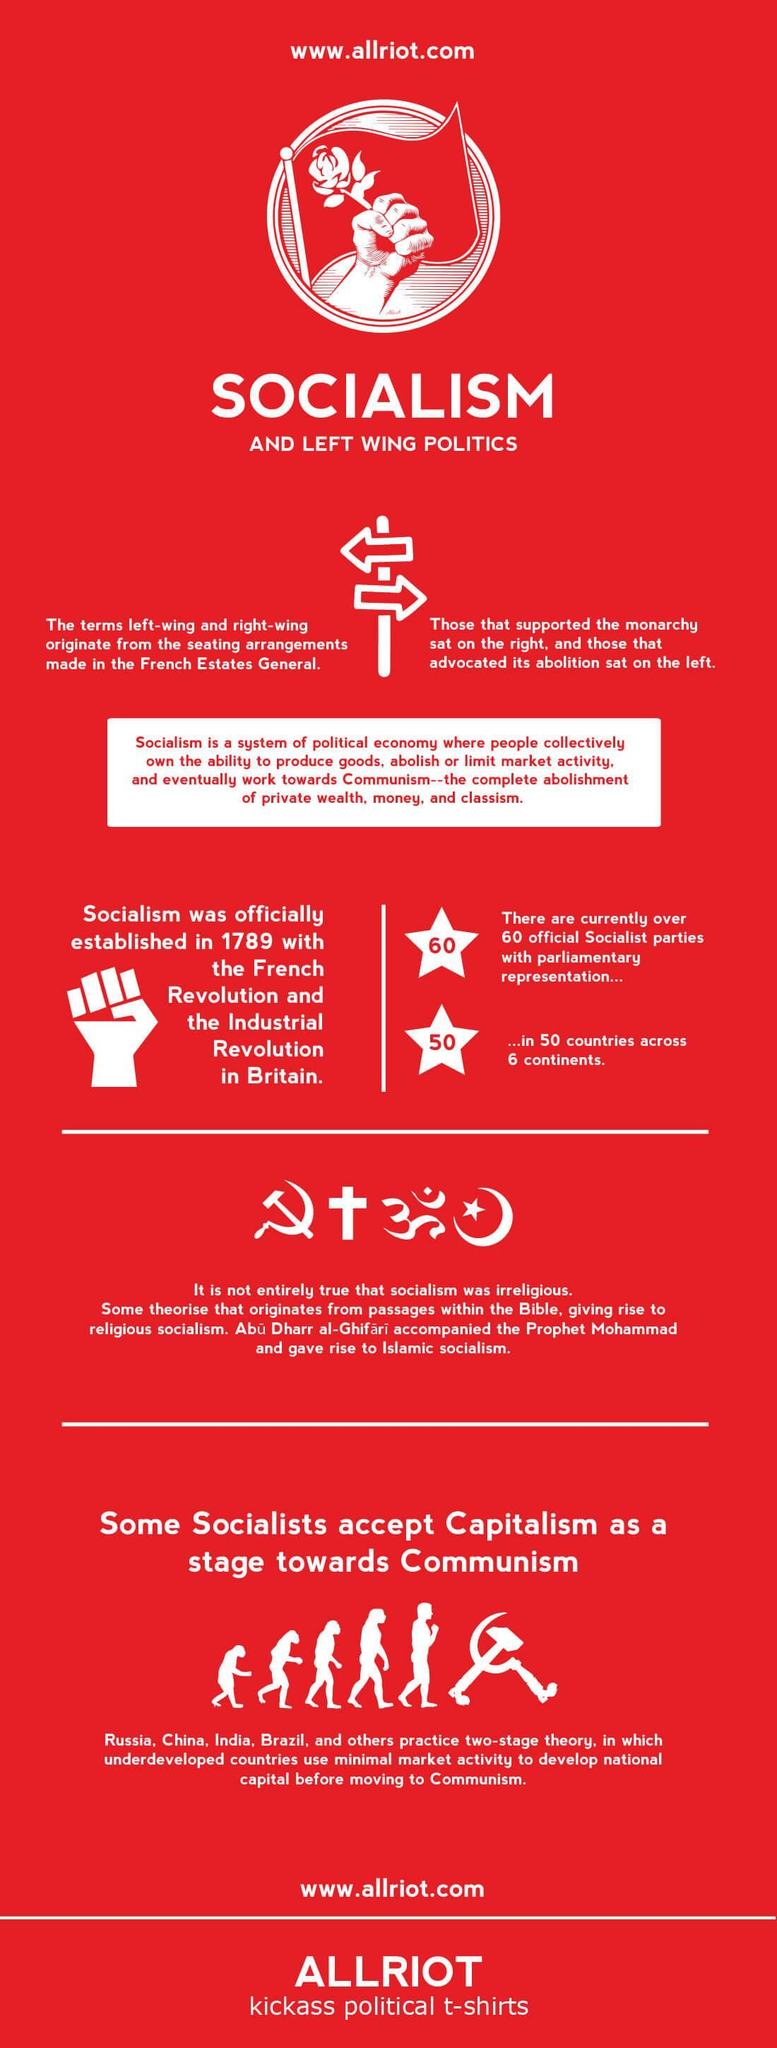On which side were those who favored monarchy seated?
Answer the question with a short phrase. right 